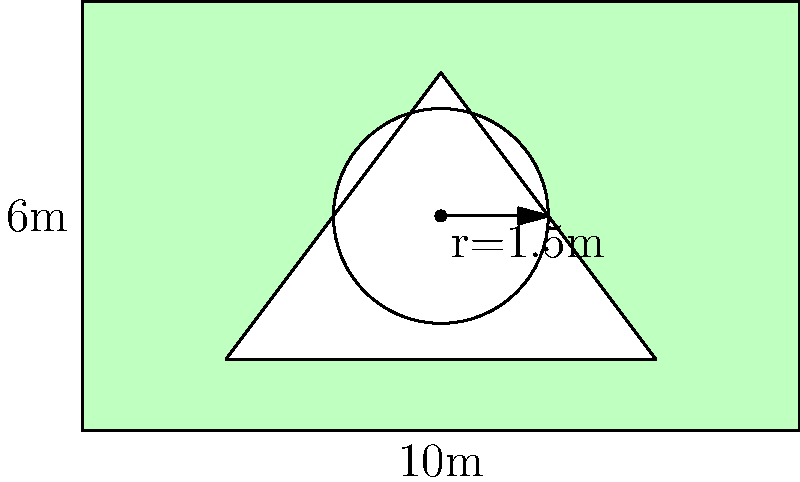A mixed-use development project includes a rectangular plot measuring 10m by 6m. Within this plot, there's a circular fountain with a radius of 1.5m at the center and a triangular paved area with vertices at (2,1), (8,1), and (5,5). The remaining area is designated as green space. What percentage of the total plot area is allocated to green space? Round your answer to the nearest whole percent. Let's approach this step-by-step:

1) Calculate the total area of the rectangular plot:
   $A_{total} = 10m \times 6m = 60m^2$

2) Calculate the area of the circular fountain:
   $A_{circle} = \pi r^2 = \pi \times (1.5m)^2 = 7.0686m^2$

3) Calculate the area of the triangular paved section:
   Base = 8m - 2m = 6m
   Height = 5m - 1m = 4m
   $A_{triangle} = \frac{1}{2} \times base \times height = \frac{1}{2} \times 6m \times 4m = 12m^2$

4) Calculate the total non-green area:
   $A_{non-green} = A_{circle} + A_{triangle} = 7.0686m^2 + 12m^2 = 19.0686m^2$

5) Calculate the green space area:
   $A_{green} = A_{total} - A_{non-green} = 60m^2 - 19.0686m^2 = 40.9314m^2$

6) Calculate the percentage of green space:
   $Percentage = \frac{A_{green}}{A_{total}} \times 100\% = \frac{40.9314m^2}{60m^2} \times 100\% = 68.219\%$

7) Rounding to the nearest whole percent:
   68.219% rounds to 68%
Answer: 68% 